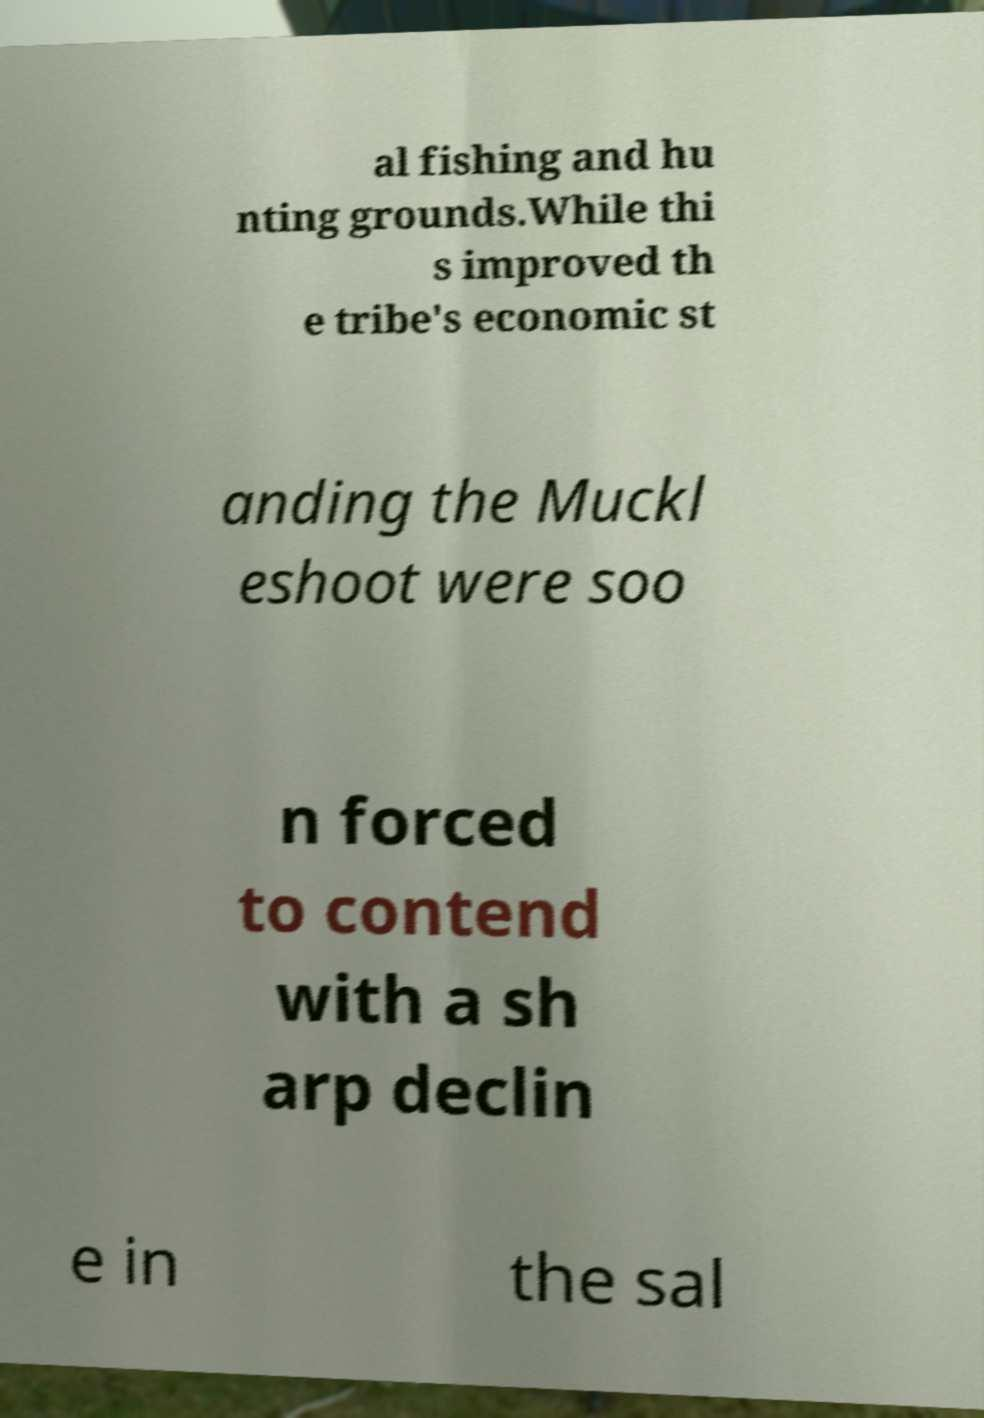Could you assist in decoding the text presented in this image and type it out clearly? al fishing and hu nting grounds.While thi s improved th e tribe's economic st anding the Muckl eshoot were soo n forced to contend with a sh arp declin e in the sal 